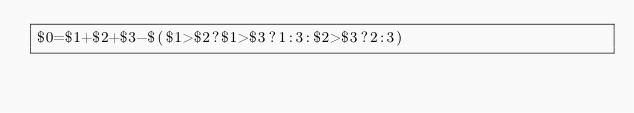Convert code to text. <code><loc_0><loc_0><loc_500><loc_500><_Awk_>$0=$1+$2+$3-$($1>$2?$1>$3?1:3:$2>$3?2:3)</code> 